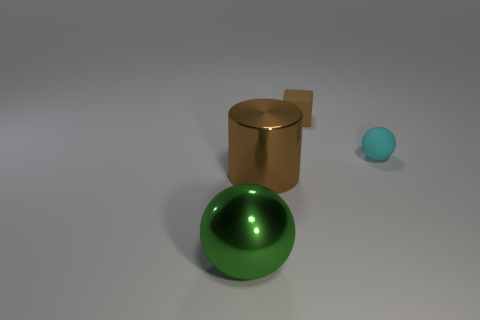Add 1 large cyan metallic objects. How many objects exist? 5 Subtract all cyan balls. How many balls are left? 1 Subtract all cubes. How many objects are left? 3 Subtract all brown spheres. How many cyan blocks are left? 0 Subtract all green cubes. Subtract all big cylinders. How many objects are left? 3 Add 1 small spheres. How many small spheres are left? 2 Add 4 tiny brown things. How many tiny brown things exist? 5 Subtract 0 brown balls. How many objects are left? 4 Subtract 1 cylinders. How many cylinders are left? 0 Subtract all cyan spheres. Subtract all red cylinders. How many spheres are left? 1 